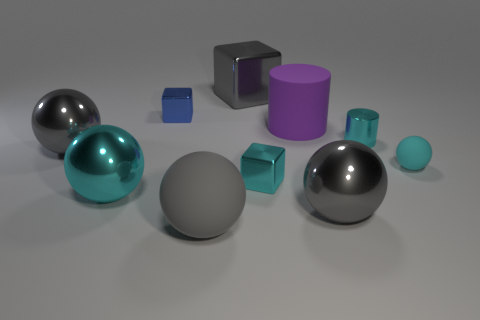Subtract all gray cubes. How many cubes are left? 2 Subtract all large matte balls. How many balls are left? 4 Subtract 0 purple spheres. How many objects are left? 10 Subtract all blocks. How many objects are left? 7 Subtract 1 cylinders. How many cylinders are left? 1 Subtract all blue blocks. Subtract all cyan balls. How many blocks are left? 2 Subtract all yellow spheres. How many cyan cubes are left? 1 Subtract all big yellow balls. Subtract all tiny cyan balls. How many objects are left? 9 Add 9 purple rubber objects. How many purple rubber objects are left? 10 Add 9 small red rubber balls. How many small red rubber balls exist? 9 